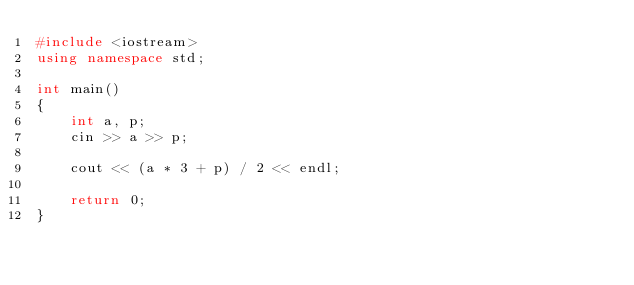<code> <loc_0><loc_0><loc_500><loc_500><_C++_>#include <iostream>
using namespace std;

int main()
{
    int a, p;
    cin >> a >> p;

    cout << (a * 3 + p) / 2 << endl;

    return 0;
}
</code> 